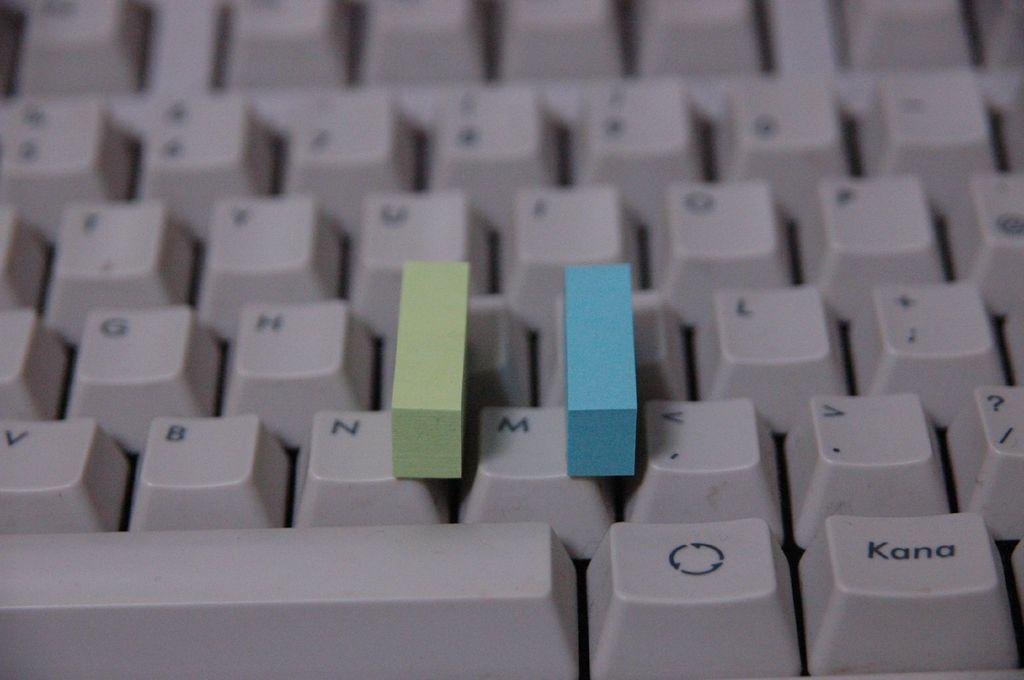What letter is in between the blocks?
Give a very brief answer. M. What letter is to the left of the green block?
Offer a very short reply. N. 